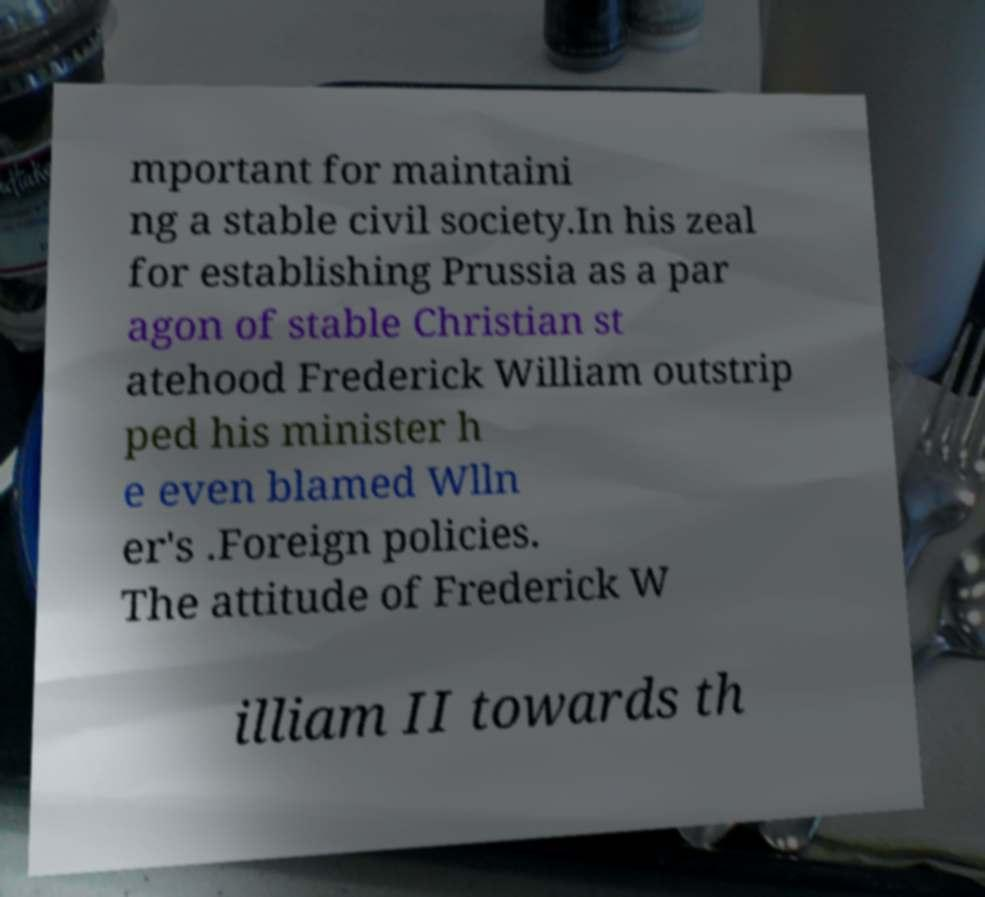Please read and relay the text visible in this image. What does it say? mportant for maintaini ng a stable civil society.In his zeal for establishing Prussia as a par agon of stable Christian st atehood Frederick William outstrip ped his minister h e even blamed Wlln er's .Foreign policies. The attitude of Frederick W illiam II towards th 